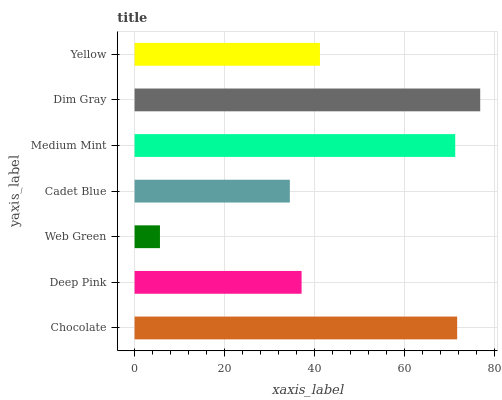Is Web Green the minimum?
Answer yes or no. Yes. Is Dim Gray the maximum?
Answer yes or no. Yes. Is Deep Pink the minimum?
Answer yes or no. No. Is Deep Pink the maximum?
Answer yes or no. No. Is Chocolate greater than Deep Pink?
Answer yes or no. Yes. Is Deep Pink less than Chocolate?
Answer yes or no. Yes. Is Deep Pink greater than Chocolate?
Answer yes or no. No. Is Chocolate less than Deep Pink?
Answer yes or no. No. Is Yellow the high median?
Answer yes or no. Yes. Is Yellow the low median?
Answer yes or no. Yes. Is Web Green the high median?
Answer yes or no. No. Is Deep Pink the low median?
Answer yes or no. No. 